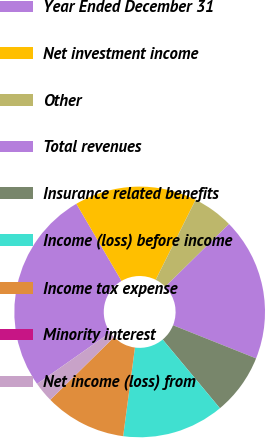Convert chart. <chart><loc_0><loc_0><loc_500><loc_500><pie_chart><fcel>Year Ended December 31<fcel>Net investment income<fcel>Other<fcel>Total revenues<fcel>Insurance related benefits<fcel>Income (loss) before income<fcel>Income tax expense<fcel>Minority interest<fcel>Net income (loss) from<nl><fcel>26.31%<fcel>15.79%<fcel>5.26%<fcel>18.42%<fcel>7.9%<fcel>13.16%<fcel>10.53%<fcel>0.0%<fcel>2.63%<nl></chart> 